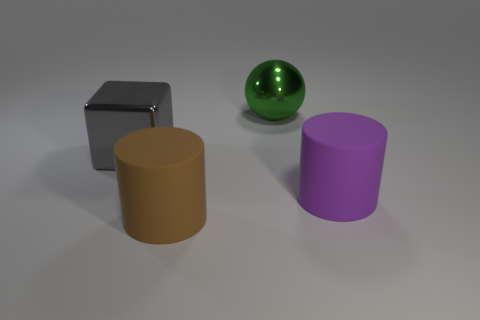Do the gray object on the left side of the green metallic sphere and the large purple thing in front of the gray cube have the same material?
Your answer should be very brief. No. There is a big purple object that is the same shape as the large brown object; what is its material?
Keep it short and to the point. Rubber. Are there any other things that are the same size as the brown matte cylinder?
Make the answer very short. Yes. Does the matte object in front of the large purple matte cylinder have the same shape as the thing behind the cube?
Ensure brevity in your answer.  No. Is the number of big green things that are left of the green metal sphere less than the number of brown rubber things that are right of the large brown rubber object?
Ensure brevity in your answer.  No. What number of other things are there of the same shape as the large gray metallic thing?
Offer a terse response. 0. The big green thing that is the same material as the big gray thing is what shape?
Your answer should be compact. Sphere. The large object that is both to the left of the large shiny sphere and in front of the big gray metallic block is what color?
Ensure brevity in your answer.  Brown. Is the big object that is to the left of the brown cylinder made of the same material as the green object?
Ensure brevity in your answer.  Yes. Are there fewer big gray metal objects that are right of the metal sphere than small green rubber objects?
Offer a terse response. No. 